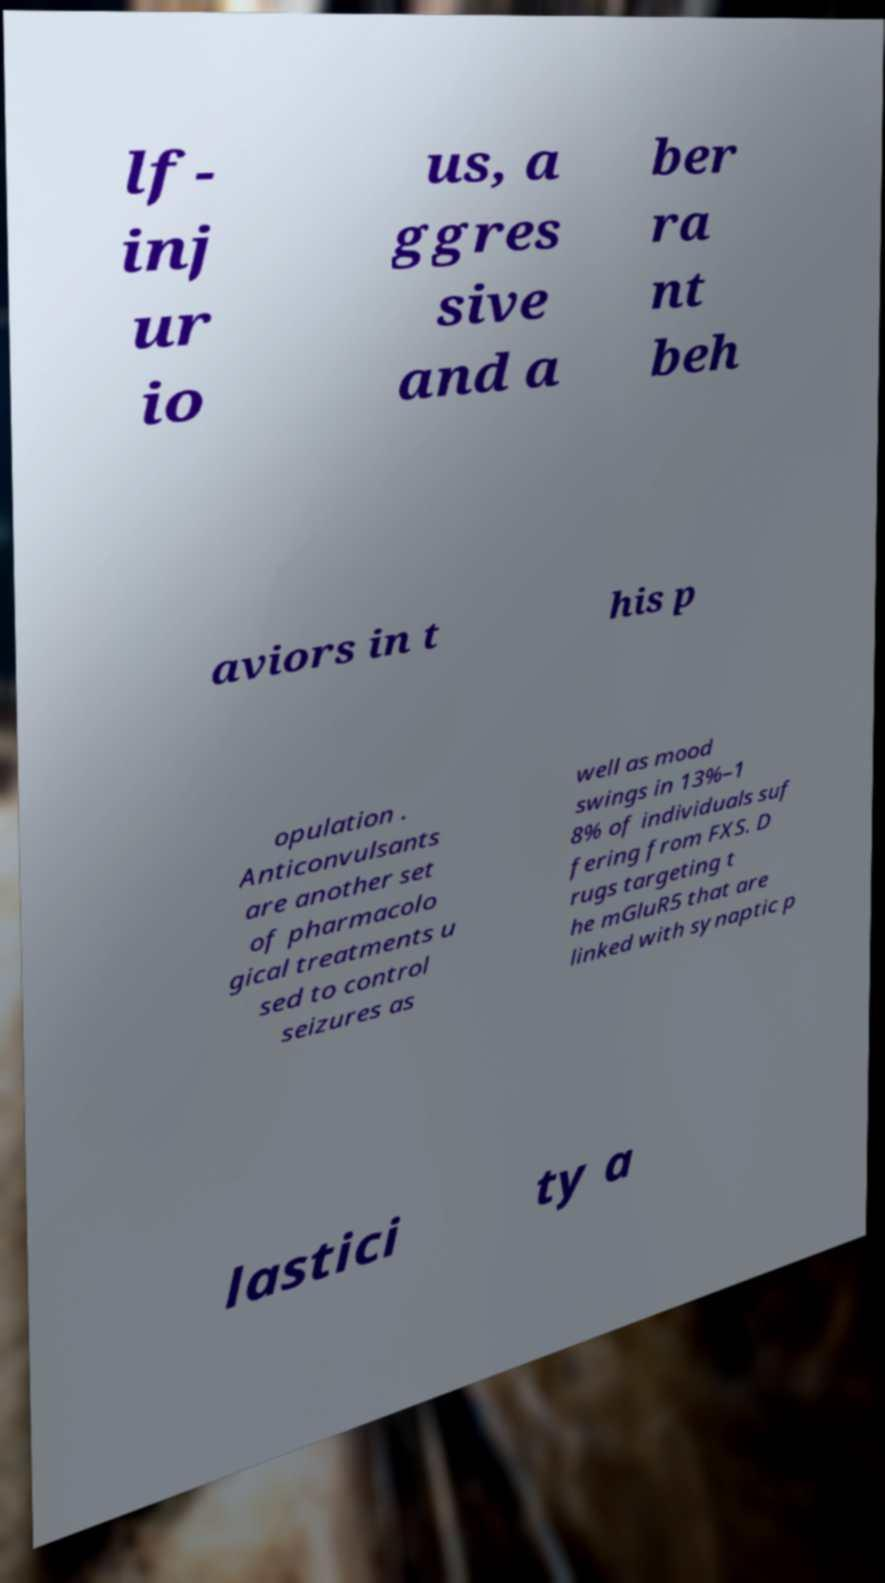Can you accurately transcribe the text from the provided image for me? lf- inj ur io us, a ggres sive and a ber ra nt beh aviors in t his p opulation . Anticonvulsants are another set of pharmacolo gical treatments u sed to control seizures as well as mood swings in 13%–1 8% of individuals suf fering from FXS. D rugs targeting t he mGluR5 that are linked with synaptic p lastici ty a 